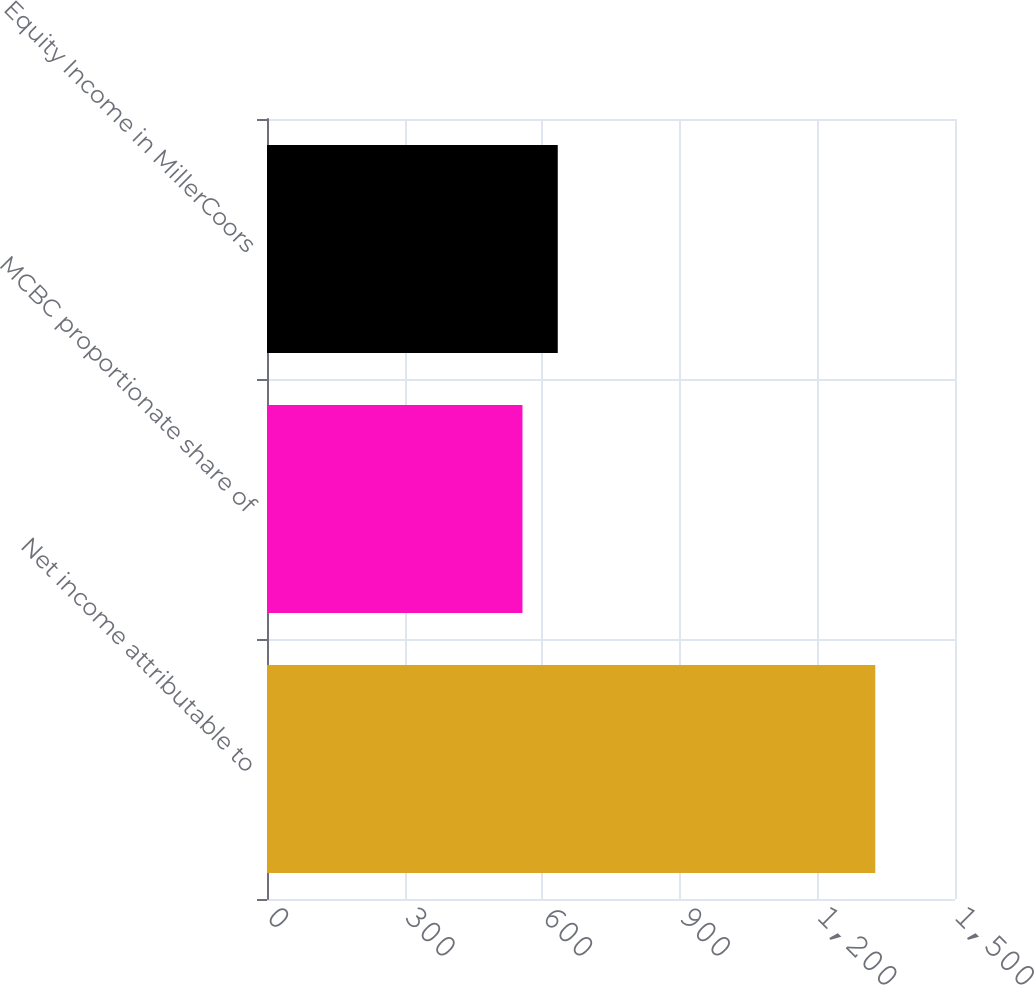<chart> <loc_0><loc_0><loc_500><loc_500><bar_chart><fcel>Net income attributable to<fcel>MCBC proportionate share of<fcel>Equity Income in MillerCoors<nl><fcel>1326.2<fcel>557<fcel>633.92<nl></chart> 